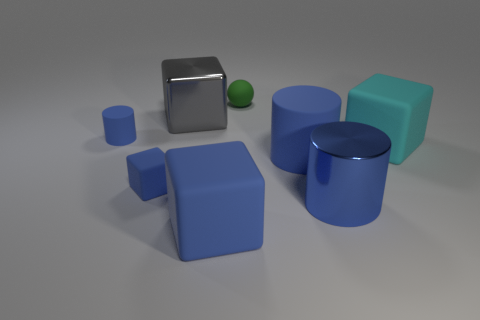Are there any small green matte things on the right side of the blue rubber object to the right of the ball on the left side of the big cyan thing?
Your response must be concise. No. There is a blue metal object; is it the same shape as the large metallic object left of the rubber sphere?
Your response must be concise. No. Is there any other thing of the same color as the big rubber cylinder?
Provide a succinct answer. Yes. Do the large cylinder that is on the left side of the blue metallic cylinder and the small rubber ball that is to the right of the small cube have the same color?
Your response must be concise. No. Is there a yellow sphere?
Your answer should be very brief. No. Is there a small green sphere made of the same material as the large gray thing?
Your answer should be very brief. No. Is there anything else that has the same material as the tiny ball?
Provide a succinct answer. Yes. The big metallic cylinder has what color?
Your response must be concise. Blue. The large metallic object that is the same color as the small rubber cube is what shape?
Offer a very short reply. Cylinder. The matte cylinder that is the same size as the metal cylinder is what color?
Offer a terse response. Blue. 